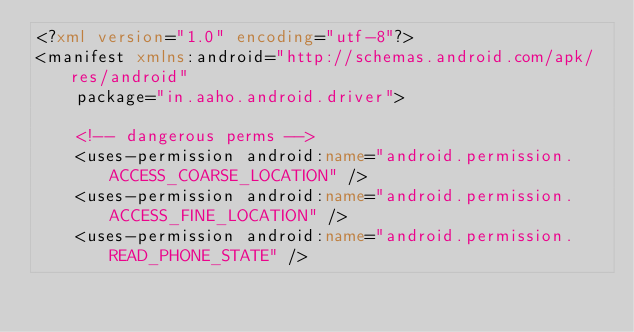<code> <loc_0><loc_0><loc_500><loc_500><_XML_><?xml version="1.0" encoding="utf-8"?>
<manifest xmlns:android="http://schemas.android.com/apk/res/android"
    package="in.aaho.android.driver">

    <!-- dangerous perms -->
    <uses-permission android:name="android.permission.ACCESS_COARSE_LOCATION" />
    <uses-permission android:name="android.permission.ACCESS_FINE_LOCATION" />
    <uses-permission android:name="android.permission.READ_PHONE_STATE" /></code> 